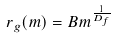Convert formula to latex. <formula><loc_0><loc_0><loc_500><loc_500>r _ { g } ( m ) = B m ^ { \frac { 1 } { D _ { f } } }</formula> 